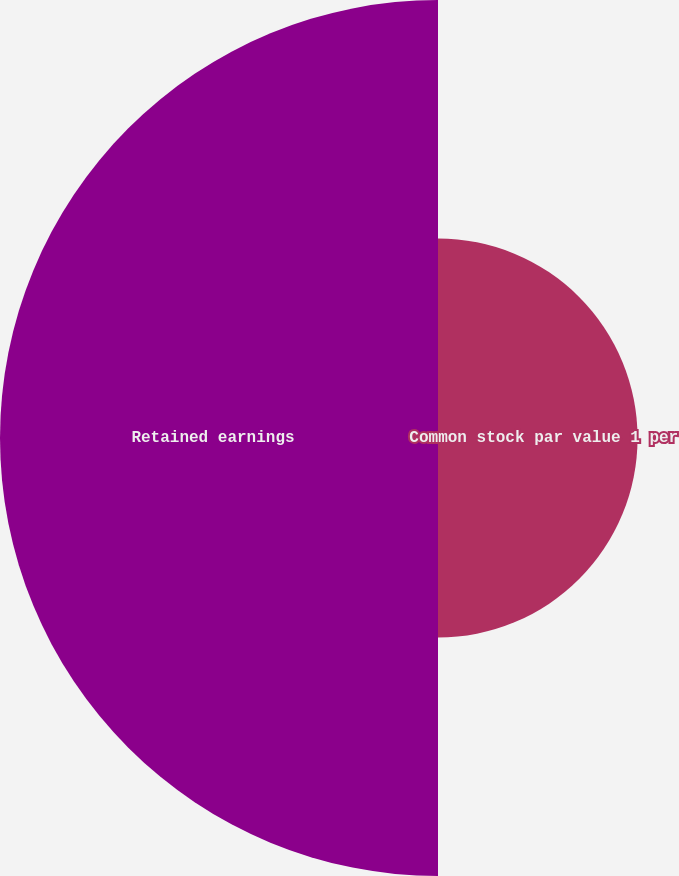<chart> <loc_0><loc_0><loc_500><loc_500><pie_chart><fcel>Common stock par value 1 per<fcel>Retained earnings<nl><fcel>31.3%<fcel>68.7%<nl></chart> 